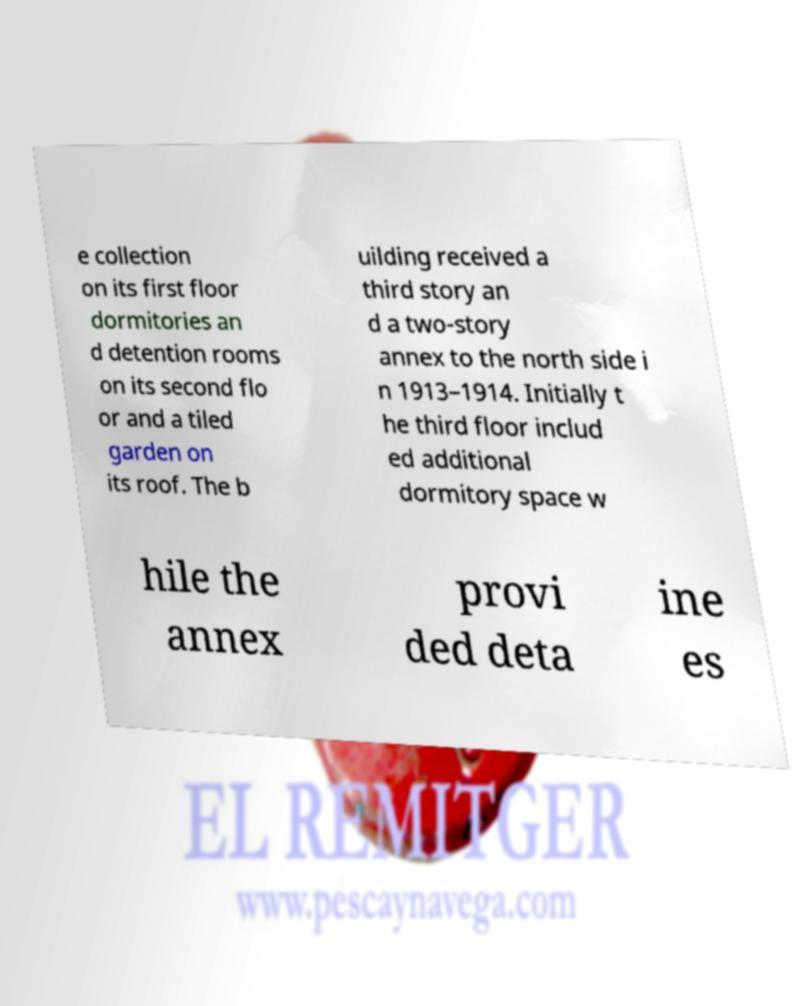I need the written content from this picture converted into text. Can you do that? e collection on its first floor dormitories an d detention rooms on its second flo or and a tiled garden on its roof. The b uilding received a third story an d a two-story annex to the north side i n 1913–1914. Initially t he third floor includ ed additional dormitory space w hile the annex provi ded deta ine es 